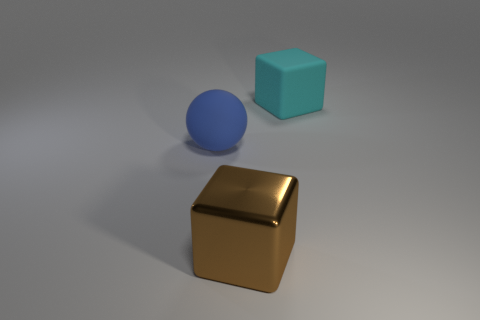Add 2 cyan shiny objects. How many objects exist? 5 Subtract 0 brown cylinders. How many objects are left? 3 Subtract all spheres. How many objects are left? 2 Subtract 1 blocks. How many blocks are left? 1 Subtract all cyan cubes. Subtract all brown cylinders. How many cubes are left? 1 Subtract all yellow cylinders. How many red cubes are left? 0 Subtract all big cyan blocks. Subtract all big blue shiny cylinders. How many objects are left? 2 Add 3 large balls. How many large balls are left? 4 Add 1 big cyan matte cubes. How many big cyan matte cubes exist? 2 Subtract all brown cubes. How many cubes are left? 1 